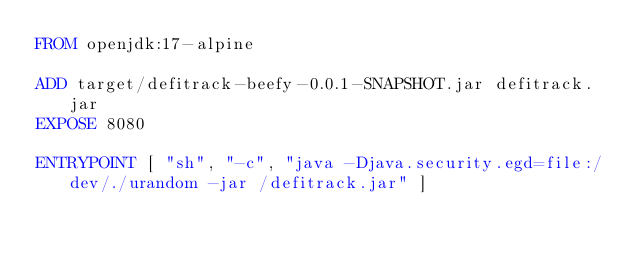<code> <loc_0><loc_0><loc_500><loc_500><_Dockerfile_>FROM openjdk:17-alpine

ADD target/defitrack-beefy-0.0.1-SNAPSHOT.jar defitrack.jar
EXPOSE 8080

ENTRYPOINT [ "sh", "-c", "java -Djava.security.egd=file:/dev/./urandom -jar /defitrack.jar" ]</code> 